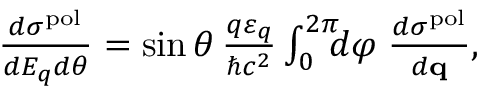<formula> <loc_0><loc_0><loc_500><loc_500>\begin{array} { r } { \frac { d \sigma ^ { p o l } } { d E _ { q } d \theta } = \sin \theta \, \frac { q \varepsilon _ { q } } { \hbar { c } ^ { 2 } } \int _ { 0 } ^ { 2 \pi } \, d \varphi \, \frac { d \sigma ^ { p o l } } { d { q } } , } \end{array}</formula> 